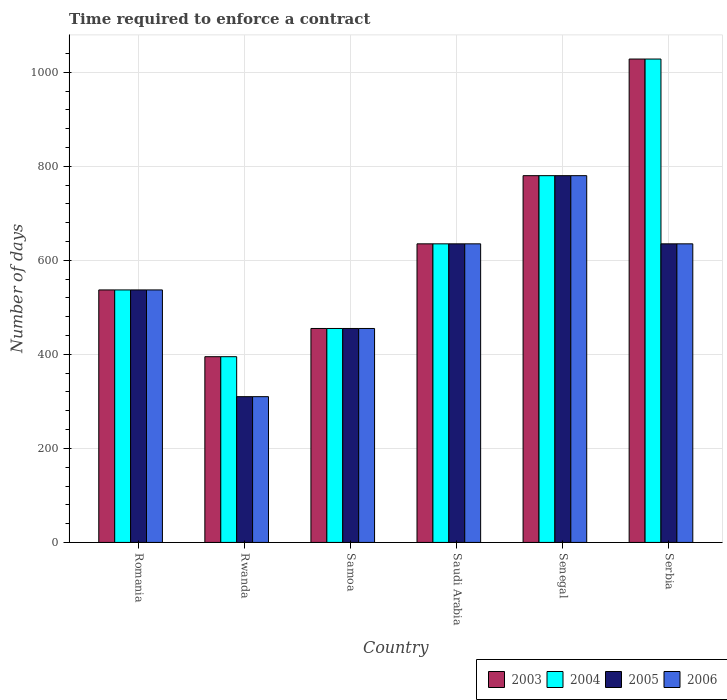Are the number of bars per tick equal to the number of legend labels?
Provide a succinct answer. Yes. How many bars are there on the 6th tick from the right?
Give a very brief answer. 4. What is the label of the 4th group of bars from the left?
Provide a succinct answer. Saudi Arabia. In how many cases, is the number of bars for a given country not equal to the number of legend labels?
Your response must be concise. 0. What is the number of days required to enforce a contract in 2003 in Romania?
Keep it short and to the point. 537. Across all countries, what is the maximum number of days required to enforce a contract in 2004?
Provide a short and direct response. 1028. Across all countries, what is the minimum number of days required to enforce a contract in 2005?
Offer a very short reply. 310. In which country was the number of days required to enforce a contract in 2004 maximum?
Your response must be concise. Serbia. In which country was the number of days required to enforce a contract in 2006 minimum?
Your response must be concise. Rwanda. What is the total number of days required to enforce a contract in 2004 in the graph?
Offer a very short reply. 3830. What is the difference between the number of days required to enforce a contract in 2004 in Rwanda and that in Saudi Arabia?
Provide a succinct answer. -240. What is the difference between the number of days required to enforce a contract in 2003 in Romania and the number of days required to enforce a contract in 2005 in Rwanda?
Make the answer very short. 227. What is the average number of days required to enforce a contract in 2006 per country?
Provide a succinct answer. 558.67. In how many countries, is the number of days required to enforce a contract in 2003 greater than 1000 days?
Give a very brief answer. 1. What is the ratio of the number of days required to enforce a contract in 2004 in Rwanda to that in Samoa?
Offer a very short reply. 0.87. What is the difference between the highest and the second highest number of days required to enforce a contract in 2006?
Your answer should be compact. -145. What is the difference between the highest and the lowest number of days required to enforce a contract in 2004?
Ensure brevity in your answer.  633. In how many countries, is the number of days required to enforce a contract in 2003 greater than the average number of days required to enforce a contract in 2003 taken over all countries?
Offer a very short reply. 2. Is the sum of the number of days required to enforce a contract in 2004 in Rwanda and Serbia greater than the maximum number of days required to enforce a contract in 2003 across all countries?
Ensure brevity in your answer.  Yes. What does the 2nd bar from the left in Rwanda represents?
Your answer should be very brief. 2004. Is it the case that in every country, the sum of the number of days required to enforce a contract in 2004 and number of days required to enforce a contract in 2006 is greater than the number of days required to enforce a contract in 2005?
Give a very brief answer. Yes. What is the difference between two consecutive major ticks on the Y-axis?
Your response must be concise. 200. Does the graph contain any zero values?
Provide a short and direct response. No. Does the graph contain grids?
Your answer should be very brief. Yes. How many legend labels are there?
Give a very brief answer. 4. How are the legend labels stacked?
Your response must be concise. Horizontal. What is the title of the graph?
Give a very brief answer. Time required to enforce a contract. Does "2004" appear as one of the legend labels in the graph?
Your answer should be compact. Yes. What is the label or title of the Y-axis?
Give a very brief answer. Number of days. What is the Number of days in 2003 in Romania?
Provide a succinct answer. 537. What is the Number of days of 2004 in Romania?
Provide a succinct answer. 537. What is the Number of days of 2005 in Romania?
Offer a terse response. 537. What is the Number of days of 2006 in Romania?
Your answer should be compact. 537. What is the Number of days in 2003 in Rwanda?
Provide a succinct answer. 395. What is the Number of days in 2004 in Rwanda?
Provide a succinct answer. 395. What is the Number of days of 2005 in Rwanda?
Offer a very short reply. 310. What is the Number of days in 2006 in Rwanda?
Give a very brief answer. 310. What is the Number of days of 2003 in Samoa?
Offer a terse response. 455. What is the Number of days of 2004 in Samoa?
Ensure brevity in your answer.  455. What is the Number of days in 2005 in Samoa?
Offer a terse response. 455. What is the Number of days of 2006 in Samoa?
Keep it short and to the point. 455. What is the Number of days in 2003 in Saudi Arabia?
Make the answer very short. 635. What is the Number of days in 2004 in Saudi Arabia?
Your answer should be compact. 635. What is the Number of days in 2005 in Saudi Arabia?
Your answer should be very brief. 635. What is the Number of days of 2006 in Saudi Arabia?
Your response must be concise. 635. What is the Number of days in 2003 in Senegal?
Your response must be concise. 780. What is the Number of days in 2004 in Senegal?
Your answer should be very brief. 780. What is the Number of days in 2005 in Senegal?
Provide a short and direct response. 780. What is the Number of days in 2006 in Senegal?
Ensure brevity in your answer.  780. What is the Number of days in 2003 in Serbia?
Offer a very short reply. 1028. What is the Number of days of 2004 in Serbia?
Offer a very short reply. 1028. What is the Number of days in 2005 in Serbia?
Offer a terse response. 635. What is the Number of days in 2006 in Serbia?
Offer a terse response. 635. Across all countries, what is the maximum Number of days of 2003?
Provide a short and direct response. 1028. Across all countries, what is the maximum Number of days in 2004?
Make the answer very short. 1028. Across all countries, what is the maximum Number of days of 2005?
Keep it short and to the point. 780. Across all countries, what is the maximum Number of days in 2006?
Make the answer very short. 780. Across all countries, what is the minimum Number of days in 2003?
Give a very brief answer. 395. Across all countries, what is the minimum Number of days of 2004?
Keep it short and to the point. 395. Across all countries, what is the minimum Number of days of 2005?
Provide a short and direct response. 310. Across all countries, what is the minimum Number of days of 2006?
Offer a terse response. 310. What is the total Number of days in 2003 in the graph?
Give a very brief answer. 3830. What is the total Number of days of 2004 in the graph?
Your answer should be compact. 3830. What is the total Number of days of 2005 in the graph?
Ensure brevity in your answer.  3352. What is the total Number of days in 2006 in the graph?
Provide a succinct answer. 3352. What is the difference between the Number of days of 2003 in Romania and that in Rwanda?
Make the answer very short. 142. What is the difference between the Number of days in 2004 in Romania and that in Rwanda?
Your response must be concise. 142. What is the difference between the Number of days in 2005 in Romania and that in Rwanda?
Provide a short and direct response. 227. What is the difference between the Number of days of 2006 in Romania and that in Rwanda?
Ensure brevity in your answer.  227. What is the difference between the Number of days of 2005 in Romania and that in Samoa?
Offer a terse response. 82. What is the difference between the Number of days of 2003 in Romania and that in Saudi Arabia?
Your answer should be very brief. -98. What is the difference between the Number of days in 2004 in Romania and that in Saudi Arabia?
Give a very brief answer. -98. What is the difference between the Number of days in 2005 in Romania and that in Saudi Arabia?
Provide a succinct answer. -98. What is the difference between the Number of days in 2006 in Romania and that in Saudi Arabia?
Offer a very short reply. -98. What is the difference between the Number of days in 2003 in Romania and that in Senegal?
Provide a short and direct response. -243. What is the difference between the Number of days in 2004 in Romania and that in Senegal?
Offer a terse response. -243. What is the difference between the Number of days of 2005 in Romania and that in Senegal?
Provide a succinct answer. -243. What is the difference between the Number of days in 2006 in Romania and that in Senegal?
Ensure brevity in your answer.  -243. What is the difference between the Number of days of 2003 in Romania and that in Serbia?
Provide a short and direct response. -491. What is the difference between the Number of days in 2004 in Romania and that in Serbia?
Offer a terse response. -491. What is the difference between the Number of days of 2005 in Romania and that in Serbia?
Give a very brief answer. -98. What is the difference between the Number of days of 2006 in Romania and that in Serbia?
Make the answer very short. -98. What is the difference between the Number of days of 2003 in Rwanda and that in Samoa?
Your answer should be compact. -60. What is the difference between the Number of days in 2004 in Rwanda and that in Samoa?
Keep it short and to the point. -60. What is the difference between the Number of days in 2005 in Rwanda and that in Samoa?
Provide a short and direct response. -145. What is the difference between the Number of days in 2006 in Rwanda and that in Samoa?
Give a very brief answer. -145. What is the difference between the Number of days of 2003 in Rwanda and that in Saudi Arabia?
Keep it short and to the point. -240. What is the difference between the Number of days in 2004 in Rwanda and that in Saudi Arabia?
Your answer should be compact. -240. What is the difference between the Number of days of 2005 in Rwanda and that in Saudi Arabia?
Make the answer very short. -325. What is the difference between the Number of days of 2006 in Rwanda and that in Saudi Arabia?
Keep it short and to the point. -325. What is the difference between the Number of days in 2003 in Rwanda and that in Senegal?
Your response must be concise. -385. What is the difference between the Number of days of 2004 in Rwanda and that in Senegal?
Your answer should be very brief. -385. What is the difference between the Number of days of 2005 in Rwanda and that in Senegal?
Ensure brevity in your answer.  -470. What is the difference between the Number of days in 2006 in Rwanda and that in Senegal?
Your response must be concise. -470. What is the difference between the Number of days of 2003 in Rwanda and that in Serbia?
Give a very brief answer. -633. What is the difference between the Number of days in 2004 in Rwanda and that in Serbia?
Give a very brief answer. -633. What is the difference between the Number of days of 2005 in Rwanda and that in Serbia?
Provide a succinct answer. -325. What is the difference between the Number of days of 2006 in Rwanda and that in Serbia?
Provide a succinct answer. -325. What is the difference between the Number of days in 2003 in Samoa and that in Saudi Arabia?
Keep it short and to the point. -180. What is the difference between the Number of days of 2004 in Samoa and that in Saudi Arabia?
Ensure brevity in your answer.  -180. What is the difference between the Number of days in 2005 in Samoa and that in Saudi Arabia?
Offer a terse response. -180. What is the difference between the Number of days in 2006 in Samoa and that in Saudi Arabia?
Make the answer very short. -180. What is the difference between the Number of days of 2003 in Samoa and that in Senegal?
Your answer should be compact. -325. What is the difference between the Number of days in 2004 in Samoa and that in Senegal?
Provide a succinct answer. -325. What is the difference between the Number of days in 2005 in Samoa and that in Senegal?
Offer a terse response. -325. What is the difference between the Number of days in 2006 in Samoa and that in Senegal?
Make the answer very short. -325. What is the difference between the Number of days in 2003 in Samoa and that in Serbia?
Offer a very short reply. -573. What is the difference between the Number of days in 2004 in Samoa and that in Serbia?
Make the answer very short. -573. What is the difference between the Number of days of 2005 in Samoa and that in Serbia?
Provide a short and direct response. -180. What is the difference between the Number of days of 2006 in Samoa and that in Serbia?
Your answer should be compact. -180. What is the difference between the Number of days of 2003 in Saudi Arabia and that in Senegal?
Provide a succinct answer. -145. What is the difference between the Number of days of 2004 in Saudi Arabia and that in Senegal?
Provide a short and direct response. -145. What is the difference between the Number of days of 2005 in Saudi Arabia and that in Senegal?
Make the answer very short. -145. What is the difference between the Number of days of 2006 in Saudi Arabia and that in Senegal?
Keep it short and to the point. -145. What is the difference between the Number of days of 2003 in Saudi Arabia and that in Serbia?
Ensure brevity in your answer.  -393. What is the difference between the Number of days in 2004 in Saudi Arabia and that in Serbia?
Ensure brevity in your answer.  -393. What is the difference between the Number of days of 2006 in Saudi Arabia and that in Serbia?
Ensure brevity in your answer.  0. What is the difference between the Number of days in 2003 in Senegal and that in Serbia?
Give a very brief answer. -248. What is the difference between the Number of days in 2004 in Senegal and that in Serbia?
Give a very brief answer. -248. What is the difference between the Number of days in 2005 in Senegal and that in Serbia?
Keep it short and to the point. 145. What is the difference between the Number of days of 2006 in Senegal and that in Serbia?
Your answer should be very brief. 145. What is the difference between the Number of days in 2003 in Romania and the Number of days in 2004 in Rwanda?
Your response must be concise. 142. What is the difference between the Number of days in 2003 in Romania and the Number of days in 2005 in Rwanda?
Offer a terse response. 227. What is the difference between the Number of days in 2003 in Romania and the Number of days in 2006 in Rwanda?
Ensure brevity in your answer.  227. What is the difference between the Number of days of 2004 in Romania and the Number of days of 2005 in Rwanda?
Offer a terse response. 227. What is the difference between the Number of days of 2004 in Romania and the Number of days of 2006 in Rwanda?
Offer a terse response. 227. What is the difference between the Number of days of 2005 in Romania and the Number of days of 2006 in Rwanda?
Keep it short and to the point. 227. What is the difference between the Number of days of 2003 in Romania and the Number of days of 2004 in Samoa?
Offer a very short reply. 82. What is the difference between the Number of days of 2003 in Romania and the Number of days of 2004 in Saudi Arabia?
Offer a terse response. -98. What is the difference between the Number of days in 2003 in Romania and the Number of days in 2005 in Saudi Arabia?
Offer a terse response. -98. What is the difference between the Number of days in 2003 in Romania and the Number of days in 2006 in Saudi Arabia?
Offer a terse response. -98. What is the difference between the Number of days in 2004 in Romania and the Number of days in 2005 in Saudi Arabia?
Keep it short and to the point. -98. What is the difference between the Number of days in 2004 in Romania and the Number of days in 2006 in Saudi Arabia?
Your answer should be very brief. -98. What is the difference between the Number of days of 2005 in Romania and the Number of days of 2006 in Saudi Arabia?
Your answer should be compact. -98. What is the difference between the Number of days in 2003 in Romania and the Number of days in 2004 in Senegal?
Give a very brief answer. -243. What is the difference between the Number of days of 2003 in Romania and the Number of days of 2005 in Senegal?
Offer a very short reply. -243. What is the difference between the Number of days of 2003 in Romania and the Number of days of 2006 in Senegal?
Your answer should be very brief. -243. What is the difference between the Number of days in 2004 in Romania and the Number of days in 2005 in Senegal?
Offer a very short reply. -243. What is the difference between the Number of days in 2004 in Romania and the Number of days in 2006 in Senegal?
Provide a short and direct response. -243. What is the difference between the Number of days in 2005 in Romania and the Number of days in 2006 in Senegal?
Ensure brevity in your answer.  -243. What is the difference between the Number of days of 2003 in Romania and the Number of days of 2004 in Serbia?
Provide a succinct answer. -491. What is the difference between the Number of days in 2003 in Romania and the Number of days in 2005 in Serbia?
Give a very brief answer. -98. What is the difference between the Number of days of 2003 in Romania and the Number of days of 2006 in Serbia?
Make the answer very short. -98. What is the difference between the Number of days of 2004 in Romania and the Number of days of 2005 in Serbia?
Provide a short and direct response. -98. What is the difference between the Number of days in 2004 in Romania and the Number of days in 2006 in Serbia?
Your answer should be very brief. -98. What is the difference between the Number of days of 2005 in Romania and the Number of days of 2006 in Serbia?
Offer a terse response. -98. What is the difference between the Number of days of 2003 in Rwanda and the Number of days of 2004 in Samoa?
Provide a succinct answer. -60. What is the difference between the Number of days in 2003 in Rwanda and the Number of days in 2005 in Samoa?
Your answer should be compact. -60. What is the difference between the Number of days of 2003 in Rwanda and the Number of days of 2006 in Samoa?
Provide a succinct answer. -60. What is the difference between the Number of days in 2004 in Rwanda and the Number of days in 2005 in Samoa?
Your answer should be very brief. -60. What is the difference between the Number of days in 2004 in Rwanda and the Number of days in 2006 in Samoa?
Your answer should be very brief. -60. What is the difference between the Number of days of 2005 in Rwanda and the Number of days of 2006 in Samoa?
Keep it short and to the point. -145. What is the difference between the Number of days in 2003 in Rwanda and the Number of days in 2004 in Saudi Arabia?
Give a very brief answer. -240. What is the difference between the Number of days in 2003 in Rwanda and the Number of days in 2005 in Saudi Arabia?
Make the answer very short. -240. What is the difference between the Number of days of 2003 in Rwanda and the Number of days of 2006 in Saudi Arabia?
Offer a terse response. -240. What is the difference between the Number of days in 2004 in Rwanda and the Number of days in 2005 in Saudi Arabia?
Your answer should be compact. -240. What is the difference between the Number of days of 2004 in Rwanda and the Number of days of 2006 in Saudi Arabia?
Make the answer very short. -240. What is the difference between the Number of days in 2005 in Rwanda and the Number of days in 2006 in Saudi Arabia?
Your response must be concise. -325. What is the difference between the Number of days of 2003 in Rwanda and the Number of days of 2004 in Senegal?
Make the answer very short. -385. What is the difference between the Number of days in 2003 in Rwanda and the Number of days in 2005 in Senegal?
Give a very brief answer. -385. What is the difference between the Number of days in 2003 in Rwanda and the Number of days in 2006 in Senegal?
Provide a succinct answer. -385. What is the difference between the Number of days of 2004 in Rwanda and the Number of days of 2005 in Senegal?
Offer a terse response. -385. What is the difference between the Number of days in 2004 in Rwanda and the Number of days in 2006 in Senegal?
Give a very brief answer. -385. What is the difference between the Number of days of 2005 in Rwanda and the Number of days of 2006 in Senegal?
Make the answer very short. -470. What is the difference between the Number of days of 2003 in Rwanda and the Number of days of 2004 in Serbia?
Provide a short and direct response. -633. What is the difference between the Number of days in 2003 in Rwanda and the Number of days in 2005 in Serbia?
Offer a very short reply. -240. What is the difference between the Number of days in 2003 in Rwanda and the Number of days in 2006 in Serbia?
Ensure brevity in your answer.  -240. What is the difference between the Number of days in 2004 in Rwanda and the Number of days in 2005 in Serbia?
Make the answer very short. -240. What is the difference between the Number of days in 2004 in Rwanda and the Number of days in 2006 in Serbia?
Offer a terse response. -240. What is the difference between the Number of days of 2005 in Rwanda and the Number of days of 2006 in Serbia?
Offer a very short reply. -325. What is the difference between the Number of days in 2003 in Samoa and the Number of days in 2004 in Saudi Arabia?
Your answer should be compact. -180. What is the difference between the Number of days of 2003 in Samoa and the Number of days of 2005 in Saudi Arabia?
Offer a terse response. -180. What is the difference between the Number of days in 2003 in Samoa and the Number of days in 2006 in Saudi Arabia?
Provide a succinct answer. -180. What is the difference between the Number of days of 2004 in Samoa and the Number of days of 2005 in Saudi Arabia?
Offer a terse response. -180. What is the difference between the Number of days in 2004 in Samoa and the Number of days in 2006 in Saudi Arabia?
Provide a short and direct response. -180. What is the difference between the Number of days in 2005 in Samoa and the Number of days in 2006 in Saudi Arabia?
Your answer should be compact. -180. What is the difference between the Number of days in 2003 in Samoa and the Number of days in 2004 in Senegal?
Offer a terse response. -325. What is the difference between the Number of days in 2003 in Samoa and the Number of days in 2005 in Senegal?
Your answer should be compact. -325. What is the difference between the Number of days of 2003 in Samoa and the Number of days of 2006 in Senegal?
Offer a terse response. -325. What is the difference between the Number of days in 2004 in Samoa and the Number of days in 2005 in Senegal?
Provide a succinct answer. -325. What is the difference between the Number of days in 2004 in Samoa and the Number of days in 2006 in Senegal?
Your answer should be very brief. -325. What is the difference between the Number of days of 2005 in Samoa and the Number of days of 2006 in Senegal?
Provide a succinct answer. -325. What is the difference between the Number of days of 2003 in Samoa and the Number of days of 2004 in Serbia?
Offer a very short reply. -573. What is the difference between the Number of days of 2003 in Samoa and the Number of days of 2005 in Serbia?
Offer a terse response. -180. What is the difference between the Number of days of 2003 in Samoa and the Number of days of 2006 in Serbia?
Your response must be concise. -180. What is the difference between the Number of days of 2004 in Samoa and the Number of days of 2005 in Serbia?
Keep it short and to the point. -180. What is the difference between the Number of days in 2004 in Samoa and the Number of days in 2006 in Serbia?
Keep it short and to the point. -180. What is the difference between the Number of days in 2005 in Samoa and the Number of days in 2006 in Serbia?
Provide a succinct answer. -180. What is the difference between the Number of days of 2003 in Saudi Arabia and the Number of days of 2004 in Senegal?
Your response must be concise. -145. What is the difference between the Number of days of 2003 in Saudi Arabia and the Number of days of 2005 in Senegal?
Your answer should be very brief. -145. What is the difference between the Number of days in 2003 in Saudi Arabia and the Number of days in 2006 in Senegal?
Provide a short and direct response. -145. What is the difference between the Number of days in 2004 in Saudi Arabia and the Number of days in 2005 in Senegal?
Your answer should be compact. -145. What is the difference between the Number of days in 2004 in Saudi Arabia and the Number of days in 2006 in Senegal?
Offer a very short reply. -145. What is the difference between the Number of days of 2005 in Saudi Arabia and the Number of days of 2006 in Senegal?
Offer a very short reply. -145. What is the difference between the Number of days in 2003 in Saudi Arabia and the Number of days in 2004 in Serbia?
Keep it short and to the point. -393. What is the difference between the Number of days in 2003 in Saudi Arabia and the Number of days in 2005 in Serbia?
Your answer should be compact. 0. What is the difference between the Number of days of 2003 in Saudi Arabia and the Number of days of 2006 in Serbia?
Ensure brevity in your answer.  0. What is the difference between the Number of days in 2004 in Saudi Arabia and the Number of days in 2005 in Serbia?
Make the answer very short. 0. What is the difference between the Number of days of 2003 in Senegal and the Number of days of 2004 in Serbia?
Offer a terse response. -248. What is the difference between the Number of days of 2003 in Senegal and the Number of days of 2005 in Serbia?
Your answer should be very brief. 145. What is the difference between the Number of days in 2003 in Senegal and the Number of days in 2006 in Serbia?
Give a very brief answer. 145. What is the difference between the Number of days of 2004 in Senegal and the Number of days of 2005 in Serbia?
Make the answer very short. 145. What is the difference between the Number of days in 2004 in Senegal and the Number of days in 2006 in Serbia?
Give a very brief answer. 145. What is the difference between the Number of days in 2005 in Senegal and the Number of days in 2006 in Serbia?
Your response must be concise. 145. What is the average Number of days of 2003 per country?
Give a very brief answer. 638.33. What is the average Number of days in 2004 per country?
Provide a short and direct response. 638.33. What is the average Number of days of 2005 per country?
Provide a short and direct response. 558.67. What is the average Number of days of 2006 per country?
Your answer should be compact. 558.67. What is the difference between the Number of days of 2004 and Number of days of 2005 in Romania?
Your response must be concise. 0. What is the difference between the Number of days in 2004 and Number of days in 2006 in Romania?
Give a very brief answer. 0. What is the difference between the Number of days of 2005 and Number of days of 2006 in Romania?
Provide a succinct answer. 0. What is the difference between the Number of days of 2003 and Number of days of 2004 in Rwanda?
Make the answer very short. 0. What is the difference between the Number of days of 2003 and Number of days of 2005 in Rwanda?
Your answer should be compact. 85. What is the difference between the Number of days of 2003 and Number of days of 2006 in Rwanda?
Provide a short and direct response. 85. What is the difference between the Number of days of 2004 and Number of days of 2005 in Rwanda?
Your response must be concise. 85. What is the difference between the Number of days in 2004 and Number of days in 2006 in Rwanda?
Provide a succinct answer. 85. What is the difference between the Number of days in 2003 and Number of days in 2004 in Samoa?
Your answer should be very brief. 0. What is the difference between the Number of days in 2004 and Number of days in 2005 in Samoa?
Offer a terse response. 0. What is the difference between the Number of days in 2004 and Number of days in 2006 in Saudi Arabia?
Give a very brief answer. 0. What is the difference between the Number of days of 2005 and Number of days of 2006 in Saudi Arabia?
Keep it short and to the point. 0. What is the difference between the Number of days of 2003 and Number of days of 2005 in Senegal?
Your answer should be compact. 0. What is the difference between the Number of days in 2003 and Number of days in 2006 in Senegal?
Your answer should be compact. 0. What is the difference between the Number of days of 2004 and Number of days of 2005 in Senegal?
Your answer should be very brief. 0. What is the difference between the Number of days in 2004 and Number of days in 2006 in Senegal?
Provide a succinct answer. 0. What is the difference between the Number of days of 2003 and Number of days of 2005 in Serbia?
Give a very brief answer. 393. What is the difference between the Number of days of 2003 and Number of days of 2006 in Serbia?
Make the answer very short. 393. What is the difference between the Number of days of 2004 and Number of days of 2005 in Serbia?
Make the answer very short. 393. What is the difference between the Number of days in 2004 and Number of days in 2006 in Serbia?
Provide a succinct answer. 393. What is the ratio of the Number of days of 2003 in Romania to that in Rwanda?
Your answer should be very brief. 1.36. What is the ratio of the Number of days in 2004 in Romania to that in Rwanda?
Offer a very short reply. 1.36. What is the ratio of the Number of days in 2005 in Romania to that in Rwanda?
Offer a terse response. 1.73. What is the ratio of the Number of days in 2006 in Romania to that in Rwanda?
Provide a short and direct response. 1.73. What is the ratio of the Number of days of 2003 in Romania to that in Samoa?
Your answer should be compact. 1.18. What is the ratio of the Number of days of 2004 in Romania to that in Samoa?
Give a very brief answer. 1.18. What is the ratio of the Number of days in 2005 in Romania to that in Samoa?
Offer a very short reply. 1.18. What is the ratio of the Number of days in 2006 in Romania to that in Samoa?
Provide a short and direct response. 1.18. What is the ratio of the Number of days of 2003 in Romania to that in Saudi Arabia?
Your answer should be compact. 0.85. What is the ratio of the Number of days in 2004 in Romania to that in Saudi Arabia?
Your response must be concise. 0.85. What is the ratio of the Number of days in 2005 in Romania to that in Saudi Arabia?
Provide a succinct answer. 0.85. What is the ratio of the Number of days of 2006 in Romania to that in Saudi Arabia?
Your answer should be compact. 0.85. What is the ratio of the Number of days in 2003 in Romania to that in Senegal?
Provide a short and direct response. 0.69. What is the ratio of the Number of days of 2004 in Romania to that in Senegal?
Offer a very short reply. 0.69. What is the ratio of the Number of days in 2005 in Romania to that in Senegal?
Offer a terse response. 0.69. What is the ratio of the Number of days in 2006 in Romania to that in Senegal?
Offer a terse response. 0.69. What is the ratio of the Number of days in 2003 in Romania to that in Serbia?
Keep it short and to the point. 0.52. What is the ratio of the Number of days in 2004 in Romania to that in Serbia?
Provide a short and direct response. 0.52. What is the ratio of the Number of days of 2005 in Romania to that in Serbia?
Ensure brevity in your answer.  0.85. What is the ratio of the Number of days in 2006 in Romania to that in Serbia?
Your answer should be compact. 0.85. What is the ratio of the Number of days of 2003 in Rwanda to that in Samoa?
Offer a very short reply. 0.87. What is the ratio of the Number of days in 2004 in Rwanda to that in Samoa?
Keep it short and to the point. 0.87. What is the ratio of the Number of days in 2005 in Rwanda to that in Samoa?
Offer a terse response. 0.68. What is the ratio of the Number of days of 2006 in Rwanda to that in Samoa?
Keep it short and to the point. 0.68. What is the ratio of the Number of days of 2003 in Rwanda to that in Saudi Arabia?
Your answer should be compact. 0.62. What is the ratio of the Number of days of 2004 in Rwanda to that in Saudi Arabia?
Provide a succinct answer. 0.62. What is the ratio of the Number of days of 2005 in Rwanda to that in Saudi Arabia?
Make the answer very short. 0.49. What is the ratio of the Number of days in 2006 in Rwanda to that in Saudi Arabia?
Provide a short and direct response. 0.49. What is the ratio of the Number of days in 2003 in Rwanda to that in Senegal?
Give a very brief answer. 0.51. What is the ratio of the Number of days of 2004 in Rwanda to that in Senegal?
Give a very brief answer. 0.51. What is the ratio of the Number of days of 2005 in Rwanda to that in Senegal?
Make the answer very short. 0.4. What is the ratio of the Number of days in 2006 in Rwanda to that in Senegal?
Offer a terse response. 0.4. What is the ratio of the Number of days of 2003 in Rwanda to that in Serbia?
Your response must be concise. 0.38. What is the ratio of the Number of days in 2004 in Rwanda to that in Serbia?
Your answer should be compact. 0.38. What is the ratio of the Number of days in 2005 in Rwanda to that in Serbia?
Your response must be concise. 0.49. What is the ratio of the Number of days in 2006 in Rwanda to that in Serbia?
Ensure brevity in your answer.  0.49. What is the ratio of the Number of days of 2003 in Samoa to that in Saudi Arabia?
Provide a succinct answer. 0.72. What is the ratio of the Number of days of 2004 in Samoa to that in Saudi Arabia?
Your response must be concise. 0.72. What is the ratio of the Number of days in 2005 in Samoa to that in Saudi Arabia?
Your answer should be compact. 0.72. What is the ratio of the Number of days of 2006 in Samoa to that in Saudi Arabia?
Keep it short and to the point. 0.72. What is the ratio of the Number of days in 2003 in Samoa to that in Senegal?
Provide a short and direct response. 0.58. What is the ratio of the Number of days in 2004 in Samoa to that in Senegal?
Offer a terse response. 0.58. What is the ratio of the Number of days of 2005 in Samoa to that in Senegal?
Ensure brevity in your answer.  0.58. What is the ratio of the Number of days of 2006 in Samoa to that in Senegal?
Ensure brevity in your answer.  0.58. What is the ratio of the Number of days in 2003 in Samoa to that in Serbia?
Your answer should be compact. 0.44. What is the ratio of the Number of days in 2004 in Samoa to that in Serbia?
Make the answer very short. 0.44. What is the ratio of the Number of days in 2005 in Samoa to that in Serbia?
Your answer should be compact. 0.72. What is the ratio of the Number of days in 2006 in Samoa to that in Serbia?
Make the answer very short. 0.72. What is the ratio of the Number of days in 2003 in Saudi Arabia to that in Senegal?
Your answer should be very brief. 0.81. What is the ratio of the Number of days in 2004 in Saudi Arabia to that in Senegal?
Keep it short and to the point. 0.81. What is the ratio of the Number of days of 2005 in Saudi Arabia to that in Senegal?
Your answer should be compact. 0.81. What is the ratio of the Number of days in 2006 in Saudi Arabia to that in Senegal?
Ensure brevity in your answer.  0.81. What is the ratio of the Number of days of 2003 in Saudi Arabia to that in Serbia?
Your answer should be very brief. 0.62. What is the ratio of the Number of days in 2004 in Saudi Arabia to that in Serbia?
Your response must be concise. 0.62. What is the ratio of the Number of days in 2005 in Saudi Arabia to that in Serbia?
Keep it short and to the point. 1. What is the ratio of the Number of days in 2006 in Saudi Arabia to that in Serbia?
Ensure brevity in your answer.  1. What is the ratio of the Number of days in 2003 in Senegal to that in Serbia?
Ensure brevity in your answer.  0.76. What is the ratio of the Number of days of 2004 in Senegal to that in Serbia?
Offer a very short reply. 0.76. What is the ratio of the Number of days in 2005 in Senegal to that in Serbia?
Ensure brevity in your answer.  1.23. What is the ratio of the Number of days in 2006 in Senegal to that in Serbia?
Offer a terse response. 1.23. What is the difference between the highest and the second highest Number of days in 2003?
Offer a very short reply. 248. What is the difference between the highest and the second highest Number of days in 2004?
Keep it short and to the point. 248. What is the difference between the highest and the second highest Number of days in 2005?
Keep it short and to the point. 145. What is the difference between the highest and the second highest Number of days of 2006?
Give a very brief answer. 145. What is the difference between the highest and the lowest Number of days of 2003?
Offer a terse response. 633. What is the difference between the highest and the lowest Number of days of 2004?
Offer a very short reply. 633. What is the difference between the highest and the lowest Number of days in 2005?
Give a very brief answer. 470. What is the difference between the highest and the lowest Number of days of 2006?
Ensure brevity in your answer.  470. 